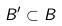Convert formula to latex. <formula><loc_0><loc_0><loc_500><loc_500>B ^ { \prime } \subset B</formula> 